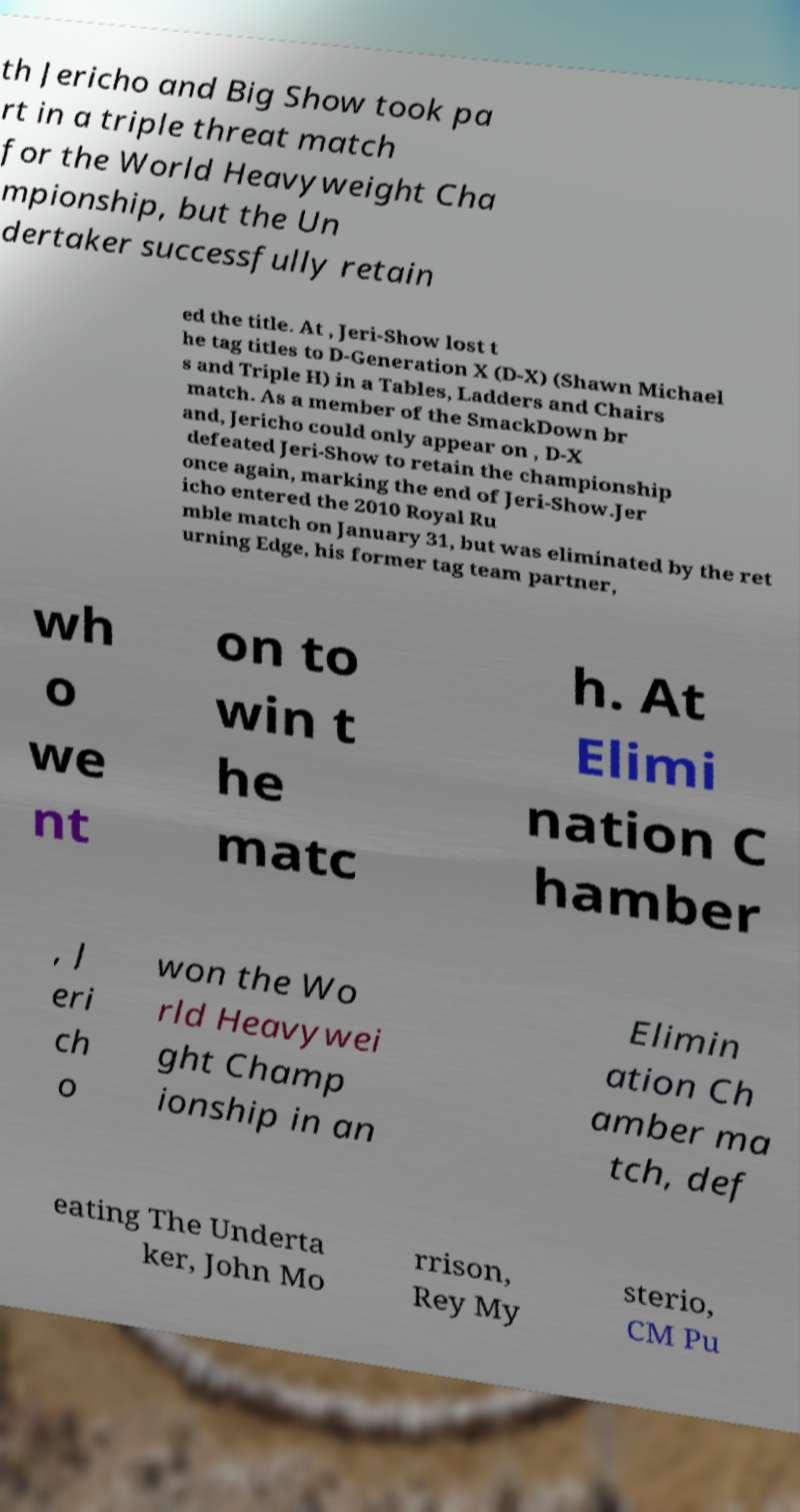Can you read and provide the text displayed in the image?This photo seems to have some interesting text. Can you extract and type it out for me? th Jericho and Big Show took pa rt in a triple threat match for the World Heavyweight Cha mpionship, but the Un dertaker successfully retain ed the title. At , Jeri-Show lost t he tag titles to D-Generation X (D-X) (Shawn Michael s and Triple H) in a Tables, Ladders and Chairs match. As a member of the SmackDown br and, Jericho could only appear on , D-X defeated Jeri-Show to retain the championship once again, marking the end of Jeri-Show.Jer icho entered the 2010 Royal Ru mble match on January 31, but was eliminated by the ret urning Edge, his former tag team partner, wh o we nt on to win t he matc h. At Elimi nation C hamber , J eri ch o won the Wo rld Heavywei ght Champ ionship in an Elimin ation Ch amber ma tch, def eating The Underta ker, John Mo rrison, Rey My sterio, CM Pu 